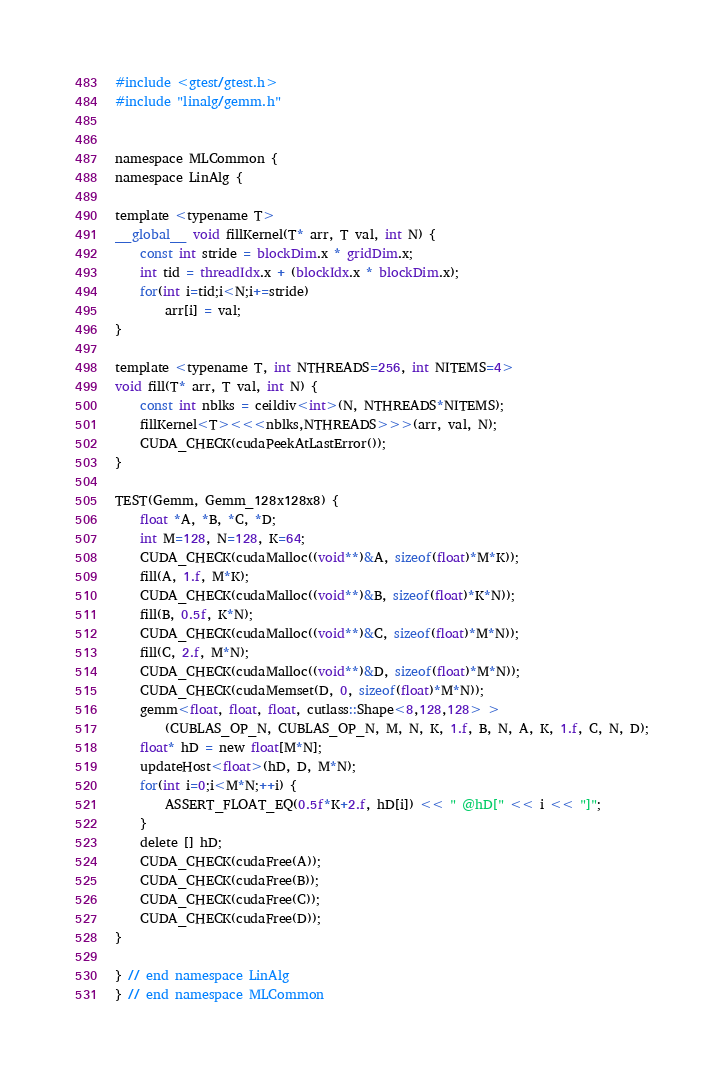<code> <loc_0><loc_0><loc_500><loc_500><_Cuda_>#include <gtest/gtest.h>
#include "linalg/gemm.h"


namespace MLCommon {
namespace LinAlg {

template <typename T>
__global__ void fillKernel(T* arr, T val, int N) {
    const int stride = blockDim.x * gridDim.x;
    int tid = threadIdx.x + (blockIdx.x * blockDim.x);
    for(int i=tid;i<N;i+=stride)
        arr[i] = val;
}

template <typename T, int NTHREADS=256, int NITEMS=4>
void fill(T* arr, T val, int N) {
    const int nblks = ceildiv<int>(N, NTHREADS*NITEMS);
    fillKernel<T><<<nblks,NTHREADS>>>(arr, val, N);
    CUDA_CHECK(cudaPeekAtLastError());
}

TEST(Gemm, Gemm_128x128x8) {
    float *A, *B, *C, *D;
    int M=128, N=128, K=64;
    CUDA_CHECK(cudaMalloc((void**)&A, sizeof(float)*M*K));
    fill(A, 1.f, M*K);
    CUDA_CHECK(cudaMalloc((void**)&B, sizeof(float)*K*N));
    fill(B, 0.5f, K*N);
    CUDA_CHECK(cudaMalloc((void**)&C, sizeof(float)*M*N));
    fill(C, 2.f, M*N);
    CUDA_CHECK(cudaMalloc((void**)&D, sizeof(float)*M*N));
    CUDA_CHECK(cudaMemset(D, 0, sizeof(float)*M*N));
    gemm<float, float, float, cutlass::Shape<8,128,128> >
        (CUBLAS_OP_N, CUBLAS_OP_N, M, N, K, 1.f, B, N, A, K, 1.f, C, N, D);
    float* hD = new float[M*N];
    updateHost<float>(hD, D, M*N);
    for(int i=0;i<M*N;++i) {
        ASSERT_FLOAT_EQ(0.5f*K+2.f, hD[i]) << " @hD[" << i << "]";
    }
    delete [] hD;
    CUDA_CHECK(cudaFree(A));
    CUDA_CHECK(cudaFree(B));
    CUDA_CHECK(cudaFree(C));
    CUDA_CHECK(cudaFree(D));
}

} // end namespace LinAlg
} // end namespace MLCommon
</code> 